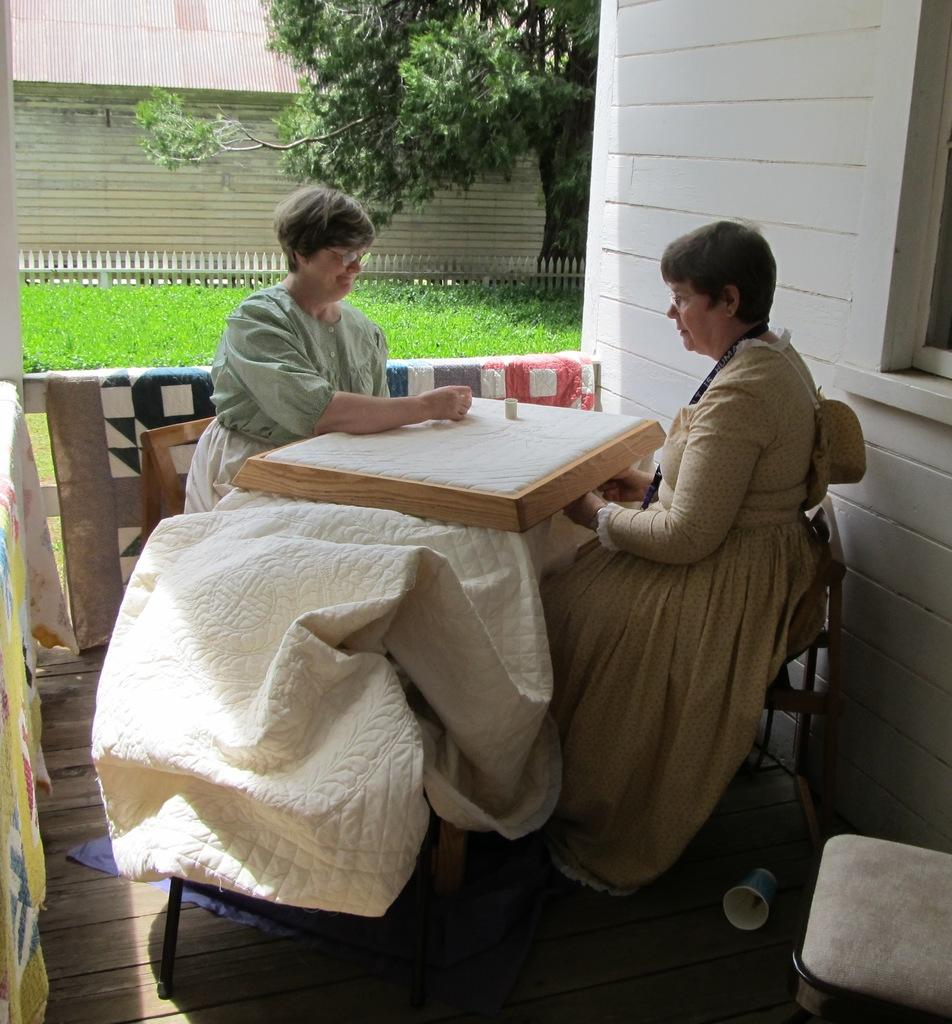How many women are in the image? There are two women in the image. What are the women doing in the image? The women are sitting on chairs. Where are the chairs located in relation to the table? The chairs are in front of a table. What can be seen in the background of the image? In the background of the image, there is a fence, grass, a tree, houses, and other objects. What type of ring can be seen on the edge of the table in the image? There is no ring present on the edge of the table in the image. What company is responsible for the design of the chairs in the image? There is no information about the company responsible for the design of the chairs in the image. 